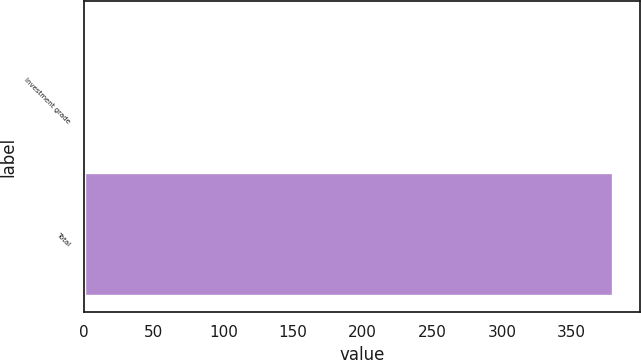Convert chart. <chart><loc_0><loc_0><loc_500><loc_500><bar_chart><fcel>Investment grade<fcel>Total<nl><fcel>1<fcel>380<nl></chart> 